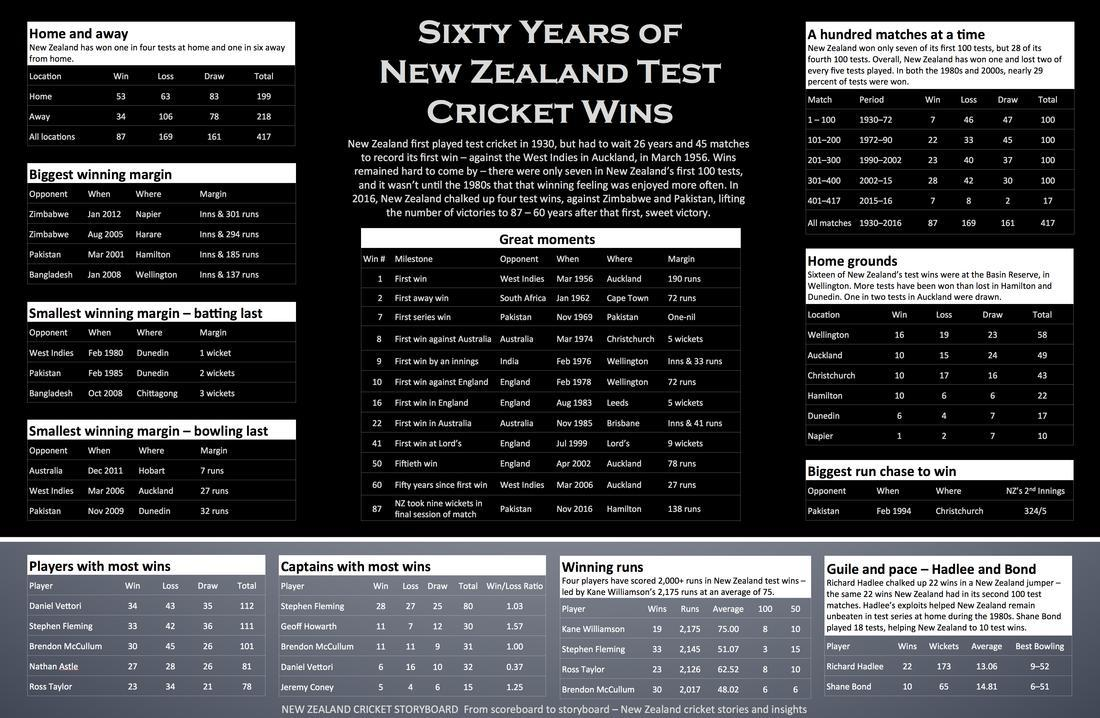How many times did Newzealand become the opponent of Australia during Newzealand's great moments?
Answer the question with a short phrase. 2 How many times did Auckland become the venue during New Zealand's great moments? 3 Against which country New Zealand has the highest running margin? Zimbabwe How many times did Newzealand become the opponent of England during Newzealand's great moments? 4 